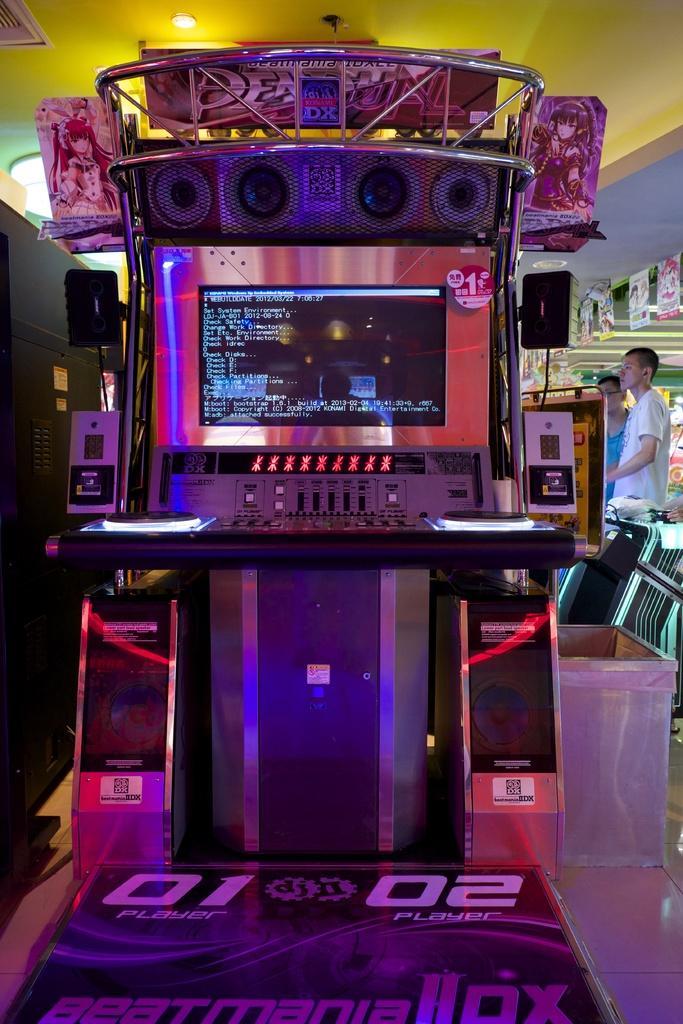How would you summarize this image in a sentence or two? In this picture we can see a machine on the floor. In the background we can see two people, posters, lights, ceiling and some objects. 